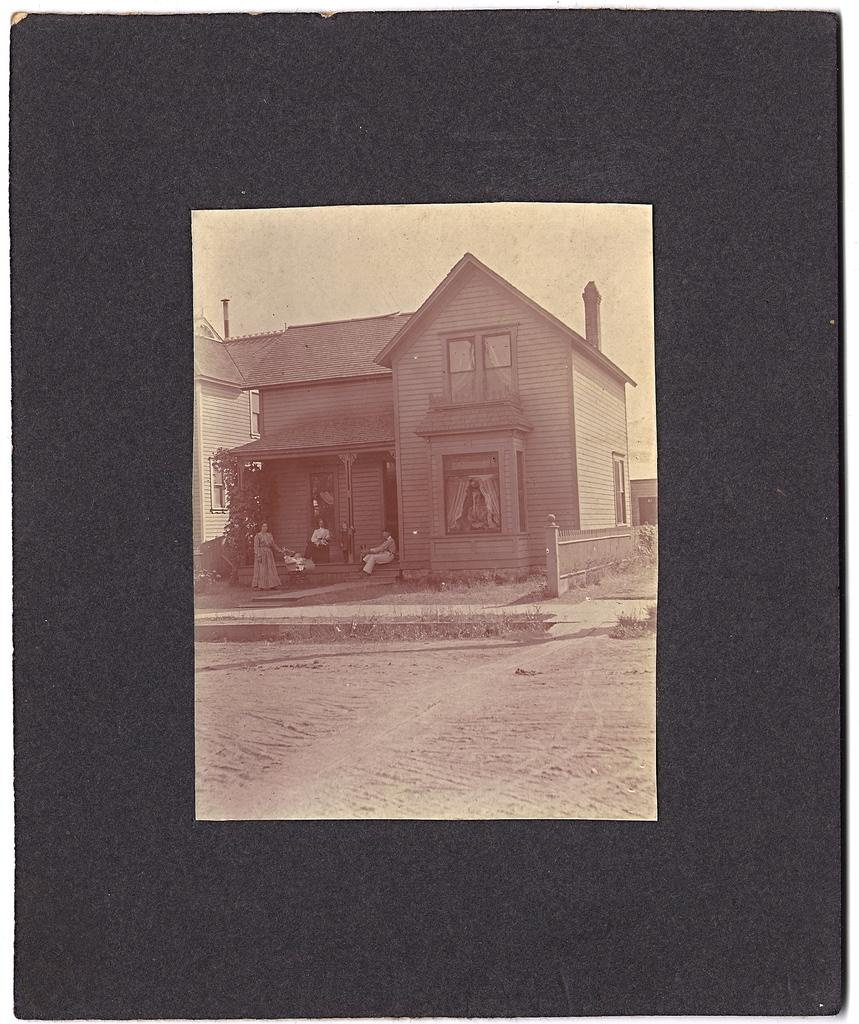What is the main subject of the image? The main subject of the image is a photo. What can be seen in the photo? The photo contains a house, sand, people, and trees. What is visible in the background of the image? There is a board visible in the background of the image. What is the reason for the chicken's presence in the image? There is no chicken present in the image, so it is not possible to determine the reason for its presence. 